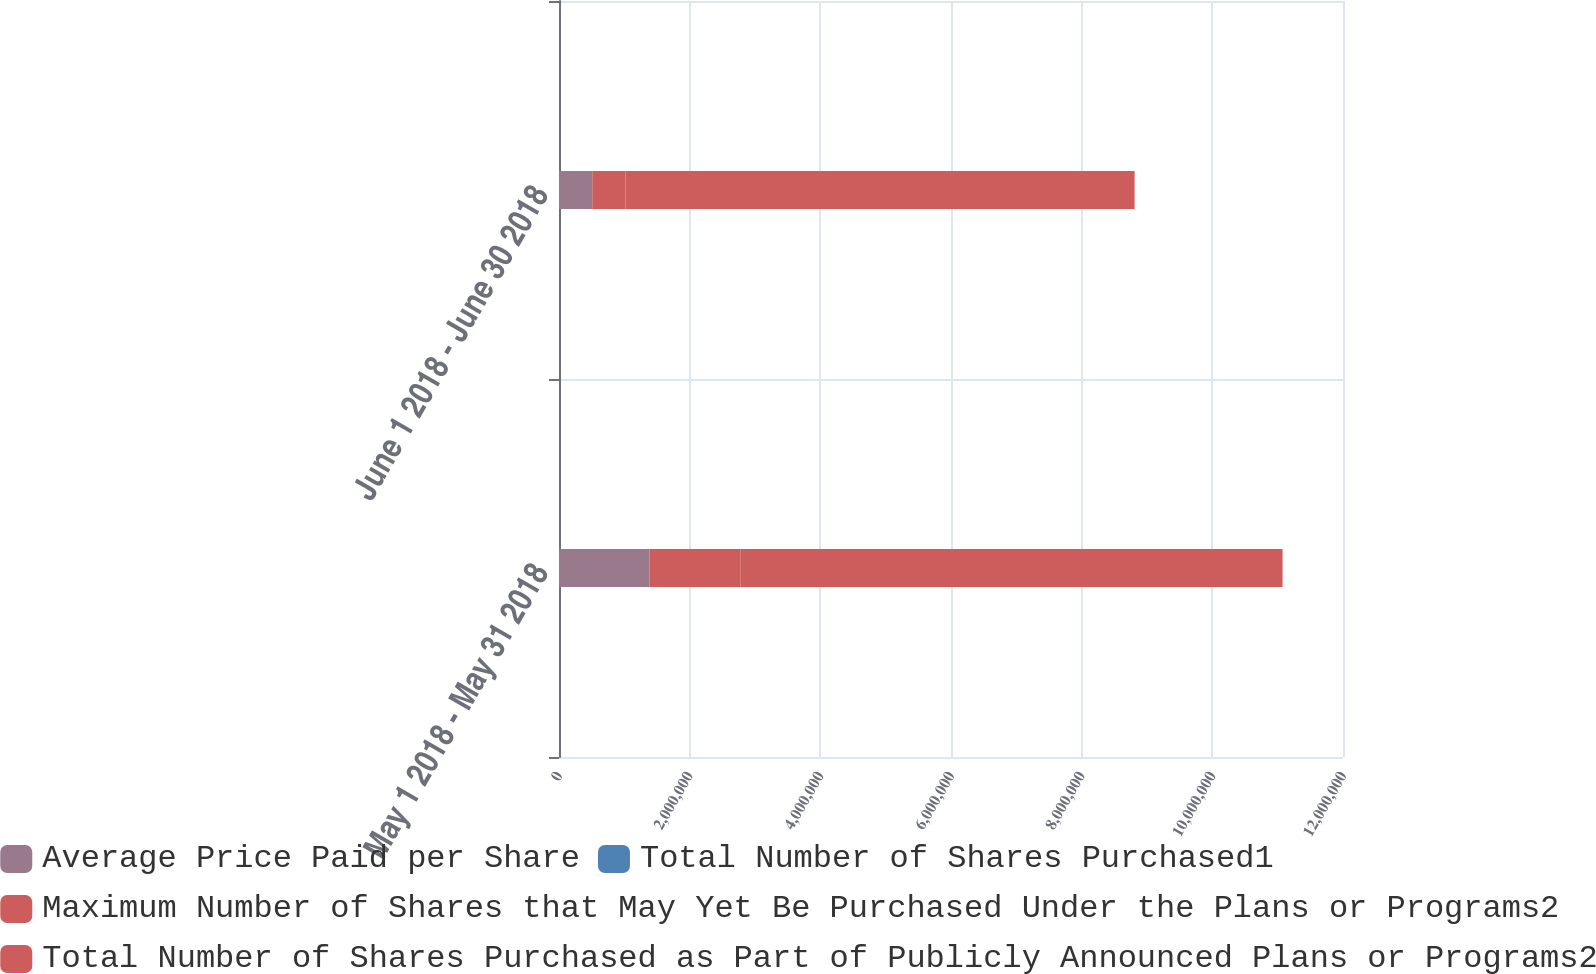Convert chart. <chart><loc_0><loc_0><loc_500><loc_500><stacked_bar_chart><ecel><fcel>May 1 2018 - May 31 2018<fcel>June 1 2018 - June 30 2018<nl><fcel>Average Price Paid per Share<fcel>1.38719e+06<fcel>509269<nl><fcel>Total Number of Shares Purchased1<fcel>115.73<fcel>118.04<nl><fcel>Maximum Number of Shares that May Yet Be Purchased Under the Plans or Programs2<fcel>1.38692e+06<fcel>509200<nl><fcel>Total Number of Shares Purchased as Part of Publicly Announced Plans or Programs2<fcel>8.30081e+06<fcel>7.79161e+06<nl></chart> 